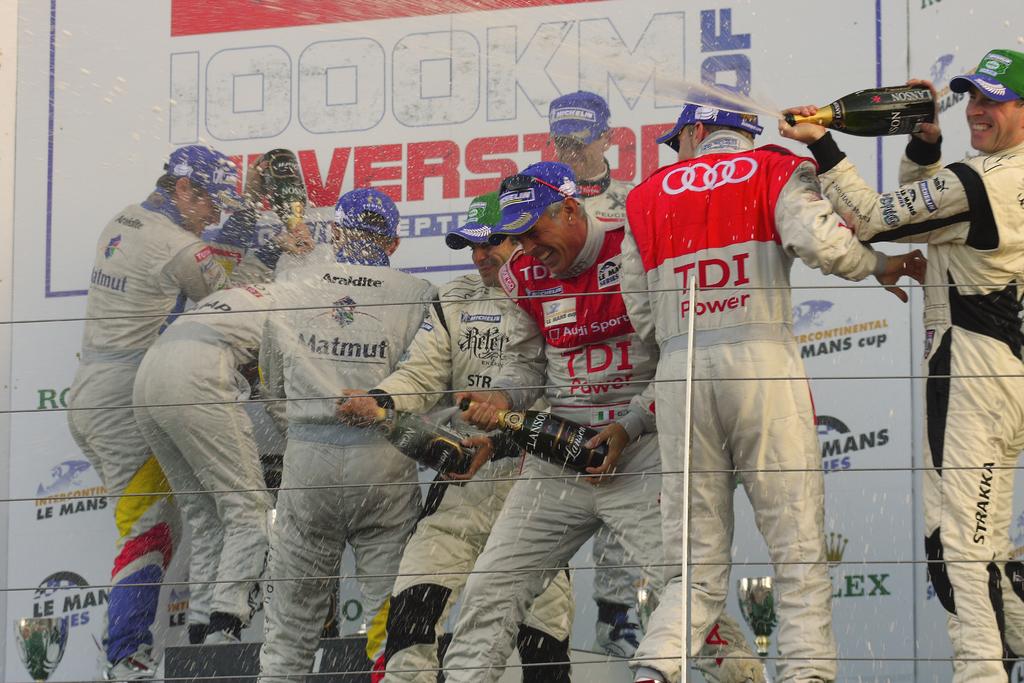What kind of power is mentioned on the red and white uniform?
Provide a short and direct response. Tdi. 